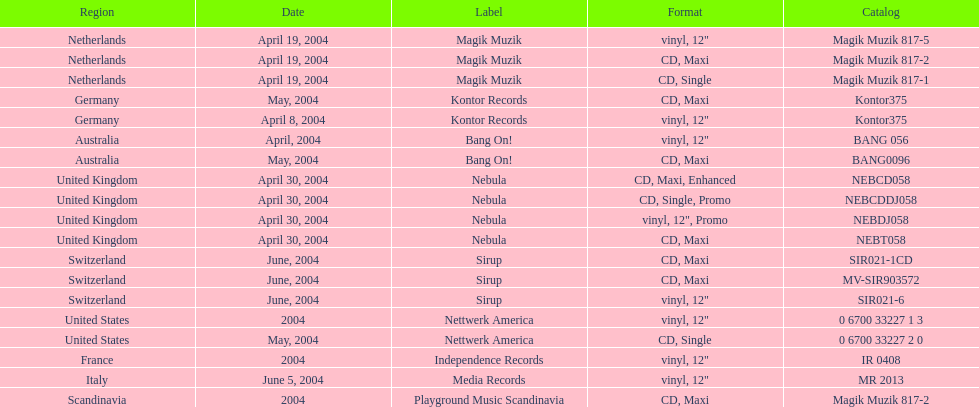What region was on the label sirup? Switzerland. 